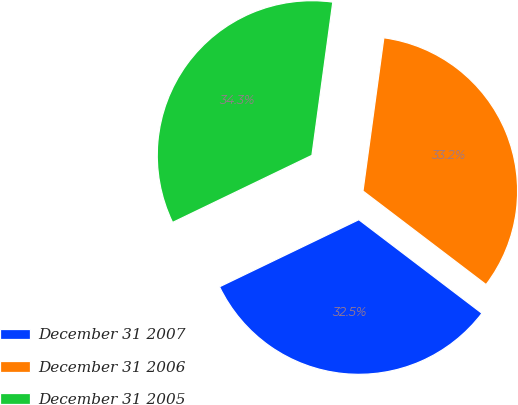Convert chart to OTSL. <chart><loc_0><loc_0><loc_500><loc_500><pie_chart><fcel>December 31 2007<fcel>December 31 2006<fcel>December 31 2005<nl><fcel>32.51%<fcel>33.19%<fcel>34.3%<nl></chart> 